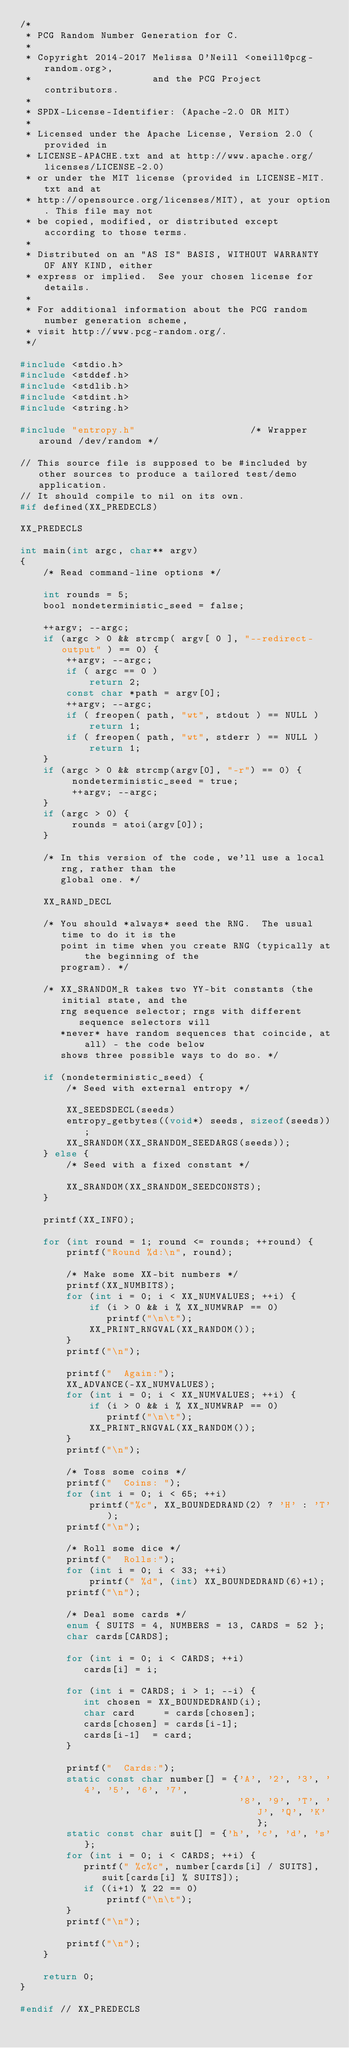<code> <loc_0><loc_0><loc_500><loc_500><_C_>/*
 * PCG Random Number Generation for C.
 *
 * Copyright 2014-2017 Melissa O'Neill <oneill@pcg-random.org>,
 *                     and the PCG Project contributors.
 *
 * SPDX-License-Identifier: (Apache-2.0 OR MIT)
 *
 * Licensed under the Apache License, Version 2.0 (provided in
 * LICENSE-APACHE.txt and at http://www.apache.org/licenses/LICENSE-2.0)
 * or under the MIT license (provided in LICENSE-MIT.txt and at
 * http://opensource.org/licenses/MIT), at your option. This file may not
 * be copied, modified, or distributed except according to those terms.
 *
 * Distributed on an "AS IS" BASIS, WITHOUT WARRANTY OF ANY KIND, either
 * express or implied.  See your chosen license for details.
 *
 * For additional information about the PCG random number generation scheme,
 * visit http://www.pcg-random.org/.
 */

#include <stdio.h>
#include <stddef.h>
#include <stdlib.h>
#include <stdint.h>
#include <string.h>

#include "entropy.h"                    /* Wrapper around /dev/random */

// This source file is supposed to be #included by other sources to produce a tailored test/demo application.
// It should compile to nil on its own.
#if defined(XX_PREDECLS)

XX_PREDECLS

int main(int argc, char** argv)
{
    /* Read command-line options */
     
    int rounds = 5;
    bool nondeterministic_seed = false;
    
    ++argv; --argc;
    if (argc > 0 && strcmp( argv[ 0 ], "--redirect-output" ) == 0) {
        ++argv; --argc;
        if ( argc == 0 )
            return 2;
        const char *path = argv[0];
        ++argv; --argc;
        if ( freopen( path, "wt", stdout ) == NULL )
            return 1;
        if ( freopen( path, "wt", stderr ) == NULL )
            return 1;
    }
    if (argc > 0 && strcmp(argv[0], "-r") == 0) {
         nondeterministic_seed = true;
         ++argv; --argc;
    }
    if (argc > 0) {
         rounds = atoi(argv[0]);
    }
    
    /* In this version of the code, we'll use a local rng, rather than the
       global one. */
    
    XX_RAND_DECL
    
    /* You should *always* seed the RNG.  The usual time to do it is the
       point in time when you create RNG (typically at the beginning of the
       program). */

    /* XX_SRANDOM_R takes two YY-bit constants (the initial state, and the
       rng sequence selector; rngs with different sequence selectors will
       *never* have random sequences that coincide, at all) - the code below
       shows three possible ways to do so. */

    if (nondeterministic_seed) {
        /* Seed with external entropy */
        
        XX_SEEDSDECL(seeds)
        entropy_getbytes((void*) seeds, sizeof(seeds)); 
        XX_SRANDOM(XX_SRANDOM_SEEDARGS(seeds));
    } else {
        /* Seed with a fixed constant */
        
        XX_SRANDOM(XX_SRANDOM_SEEDCONSTS);
    }
    
    printf(XX_INFO);
 
    for (int round = 1; round <= rounds; ++round) {
        printf("Round %d:\n", round);

        /* Make some XX-bit numbers */
        printf(XX_NUMBITS);
        for (int i = 0; i < XX_NUMVALUES; ++i) {
            if (i > 0 && i % XX_NUMWRAP == 0)
               printf("\n\t");
            XX_PRINT_RNGVAL(XX_RANDOM());
        }
        printf("\n");

        printf("  Again:");
        XX_ADVANCE(-XX_NUMVALUES);
        for (int i = 0; i < XX_NUMVALUES; ++i) {
            if (i > 0 && i % XX_NUMWRAP == 0)
               printf("\n\t");
            XX_PRINT_RNGVAL(XX_RANDOM());
        }
        printf("\n");
        
        /* Toss some coins */
        printf("  Coins: ");
        for (int i = 0; i < 65; ++i)
            printf("%c", XX_BOUNDEDRAND(2) ? 'H' : 'T');
        printf("\n");
        
        /* Roll some dice */
        printf("  Rolls:");
        for (int i = 0; i < 33; ++i)
            printf(" %d", (int) XX_BOUNDEDRAND(6)+1);
        printf("\n");
        
        /* Deal some cards */
        enum { SUITS = 4, NUMBERS = 13, CARDS = 52 };
        char cards[CARDS];
        
        for (int i = 0; i < CARDS; ++i)
           cards[i] = i;
        
        for (int i = CARDS; i > 1; --i) {
           int chosen = XX_BOUNDEDRAND(i);
           char card     = cards[chosen];
           cards[chosen] = cards[i-1];
           cards[i-1]  = card;
        }
        
        printf("  Cards:");
        static const char number[] = {'A', '2', '3', '4', '5', '6', '7',
                                      '8', '9', 'T', 'J', 'Q', 'K'};
        static const char suit[] = {'h', 'c', 'd', 's'};
        for (int i = 0; i < CARDS; ++i) {
           printf(" %c%c", number[cards[i] / SUITS], suit[cards[i] % SUITS]);
           if ((i+1) % 22 == 0)
               printf("\n\t");
        }
        printf("\n");
        
        printf("\n");
    }

    return 0;
}

#endif // XX_PREDECLS
</code> 